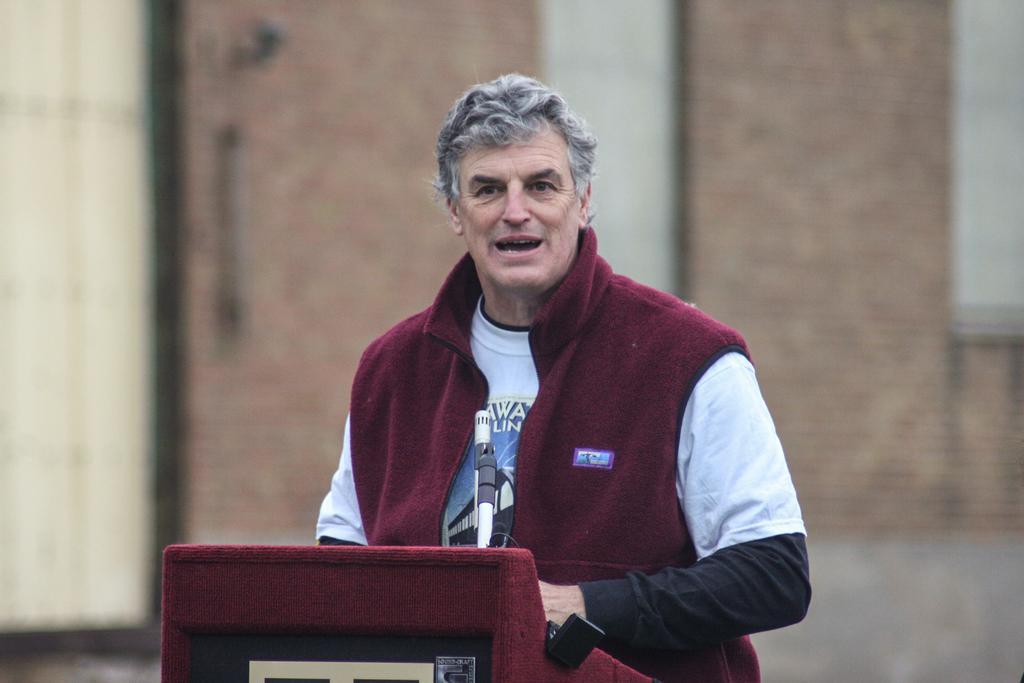Describe this image in one or two sentences. In this image I can see the person standing in front of the podium and the person is wearing maroon and white color dress and I can also see the microphone and the background is in brown and cream color. 